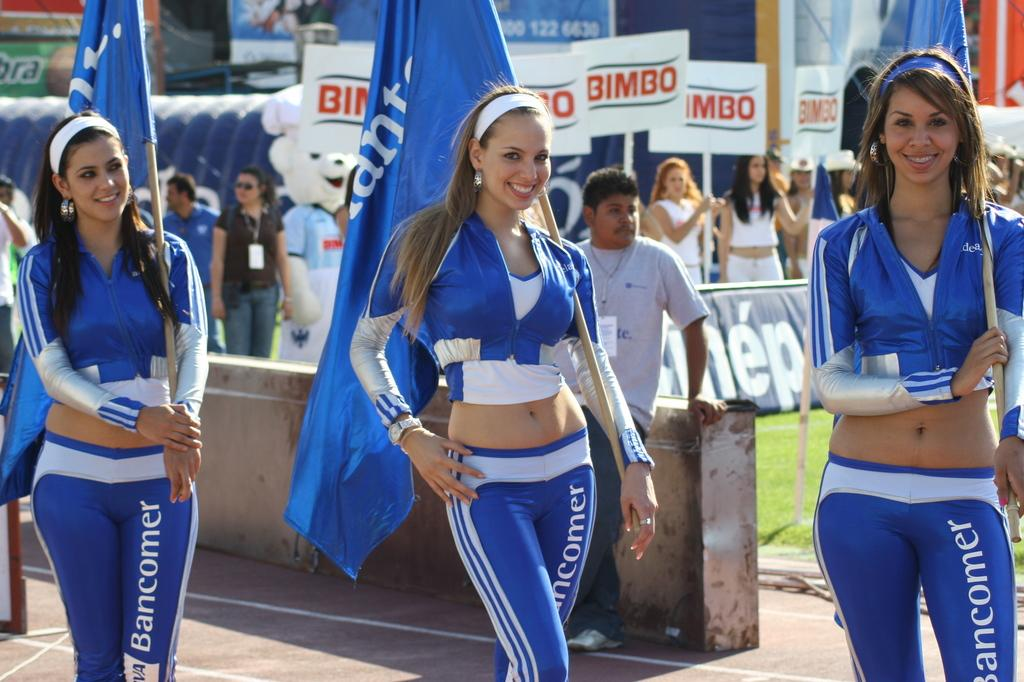<image>
Give a short and clear explanation of the subsequent image. Women modeling for something wearing pants that say "Bancomer". 